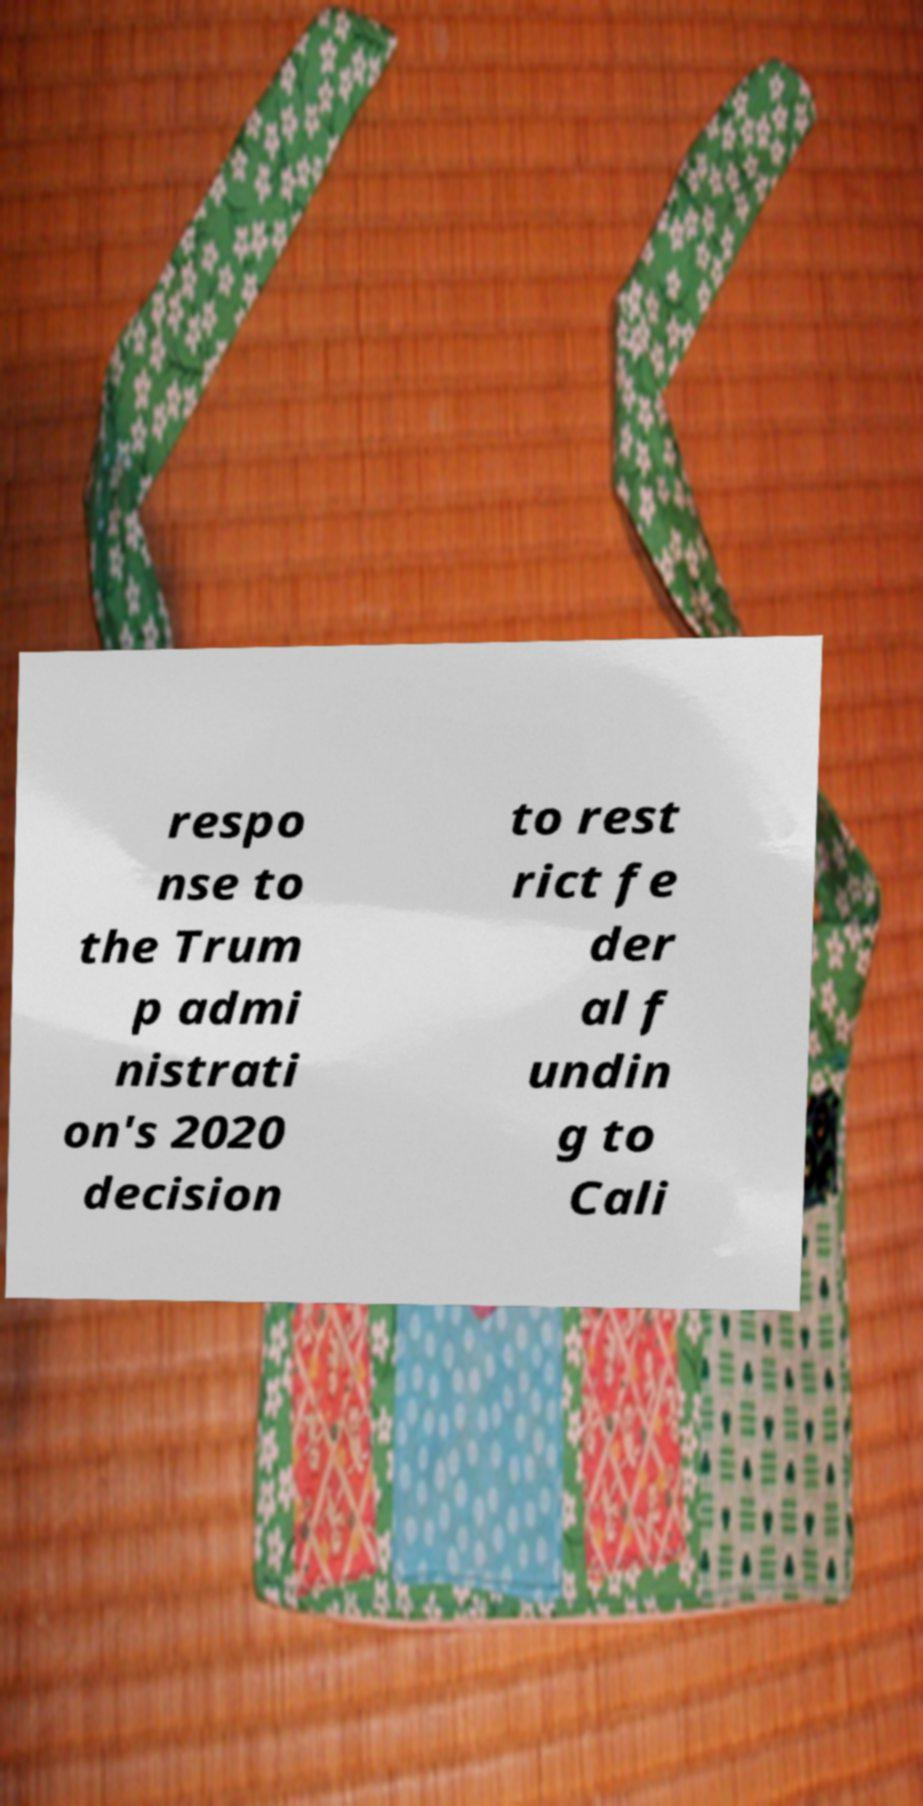Could you assist in decoding the text presented in this image and type it out clearly? respo nse to the Trum p admi nistrati on's 2020 decision to rest rict fe der al f undin g to Cali 